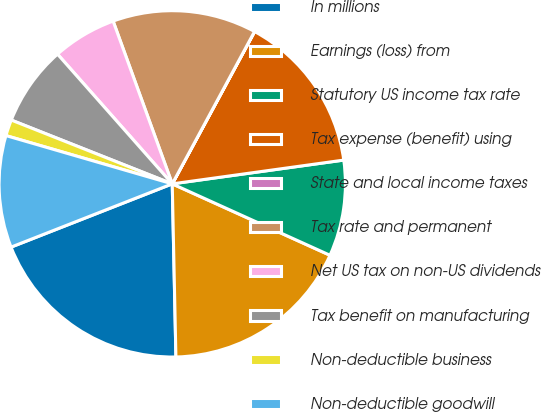Convert chart. <chart><loc_0><loc_0><loc_500><loc_500><pie_chart><fcel>In millions<fcel>Earnings (loss) from<fcel>Statutory US income tax rate<fcel>Tax expense (benefit) using<fcel>State and local income taxes<fcel>Tax rate and permanent<fcel>Net US tax on non-US dividends<fcel>Tax benefit on manufacturing<fcel>Non-deductible business<fcel>Non-deductible goodwill<nl><fcel>19.39%<fcel>17.9%<fcel>8.96%<fcel>14.92%<fcel>0.01%<fcel>13.43%<fcel>5.98%<fcel>7.47%<fcel>1.51%<fcel>10.45%<nl></chart> 